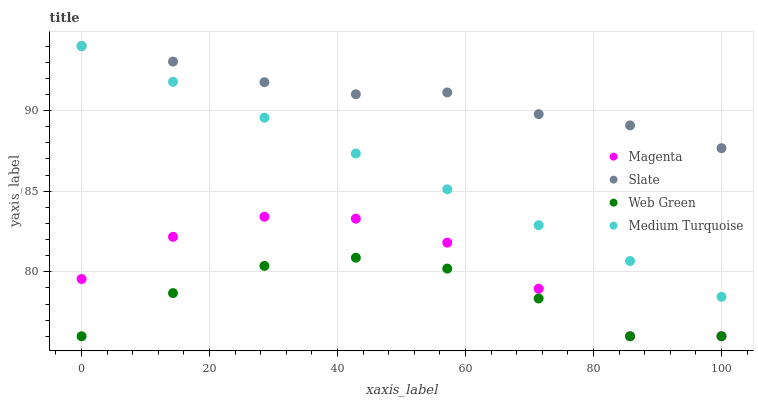Does Web Green have the minimum area under the curve?
Answer yes or no. Yes. Does Slate have the maximum area under the curve?
Answer yes or no. Yes. Does Slate have the minimum area under the curve?
Answer yes or no. No. Does Web Green have the maximum area under the curve?
Answer yes or no. No. Is Medium Turquoise the smoothest?
Answer yes or no. Yes. Is Magenta the roughest?
Answer yes or no. Yes. Is Slate the smoothest?
Answer yes or no. No. Is Slate the roughest?
Answer yes or no. No. Does Magenta have the lowest value?
Answer yes or no. Yes. Does Slate have the lowest value?
Answer yes or no. No. Does Medium Turquoise have the highest value?
Answer yes or no. Yes. Does Web Green have the highest value?
Answer yes or no. No. Is Magenta less than Medium Turquoise?
Answer yes or no. Yes. Is Medium Turquoise greater than Magenta?
Answer yes or no. Yes. Does Medium Turquoise intersect Slate?
Answer yes or no. Yes. Is Medium Turquoise less than Slate?
Answer yes or no. No. Is Medium Turquoise greater than Slate?
Answer yes or no. No. Does Magenta intersect Medium Turquoise?
Answer yes or no. No. 